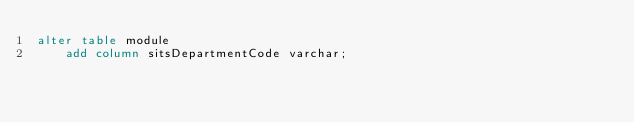Convert code to text. <code><loc_0><loc_0><loc_500><loc_500><_SQL_>alter table module
    add column sitsDepartmentCode varchar;</code> 